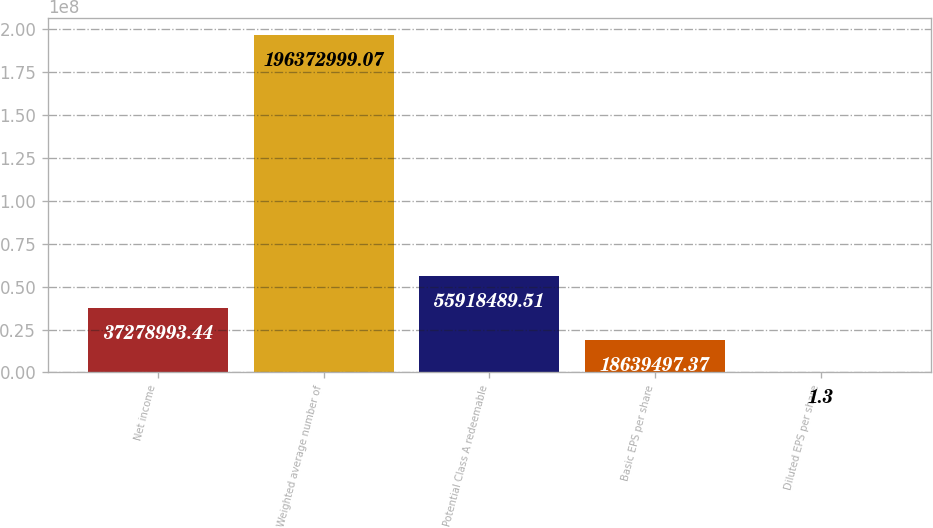<chart> <loc_0><loc_0><loc_500><loc_500><bar_chart><fcel>Net income<fcel>Weighted average number of<fcel>Potential Class A redeemable<fcel>Basic EPS per share<fcel>Diluted EPS per share<nl><fcel>3.7279e+07<fcel>1.96373e+08<fcel>5.59185e+07<fcel>1.86395e+07<fcel>1.3<nl></chart> 